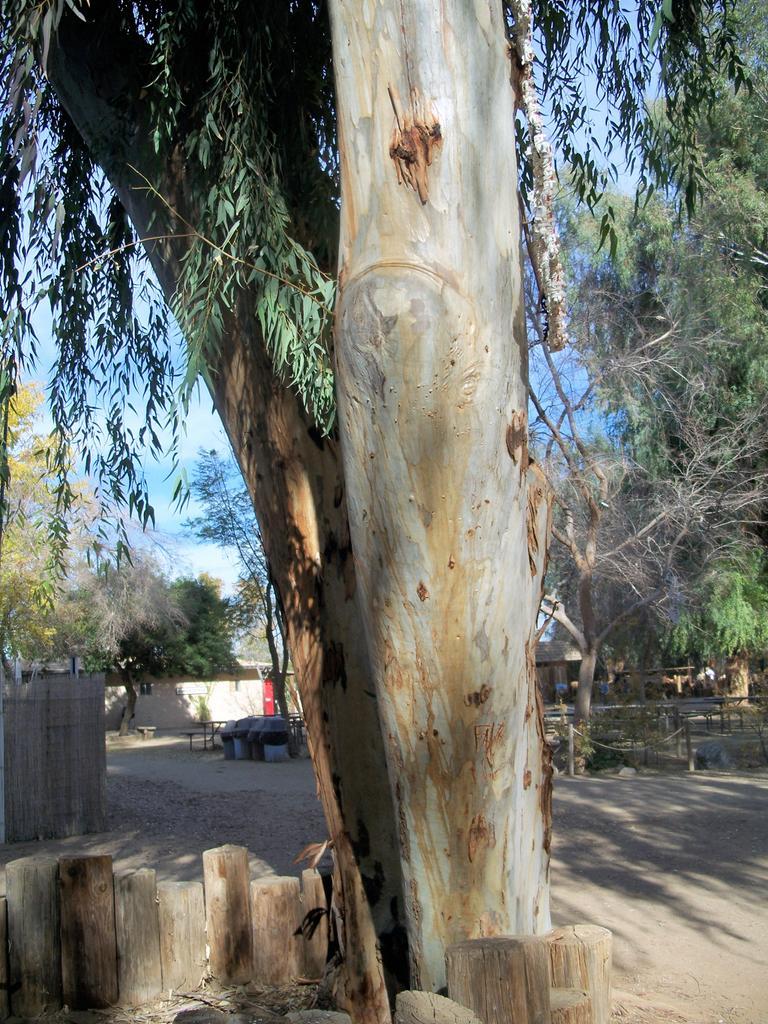Please provide a concise description of this image. In this picture, it seems like small wooden poles and a tree in the foreground area of the image, there are trees, houses and the sky in the background. 